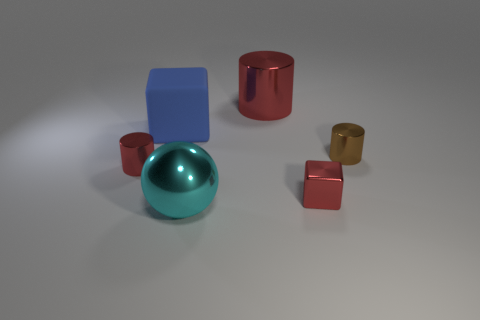There is a red object that is the same shape as the blue object; what material is it?
Make the answer very short. Metal. There is a cube behind the shiny cube; does it have the same size as the cyan metallic object?
Give a very brief answer. Yes. How many big blue things are behind the large cyan metallic object?
Keep it short and to the point. 1. Are there fewer small red cylinders to the right of the tiny red metal block than red shiny things in front of the large matte block?
Keep it short and to the point. Yes. How many big objects are there?
Provide a short and direct response. 3. The cube that is on the right side of the big cyan metal object is what color?
Provide a succinct answer. Red. The ball has what size?
Keep it short and to the point. Large. There is a big cylinder; does it have the same color as the small metallic object to the left of the large blue cube?
Keep it short and to the point. Yes. The cube that is behind the red cylinder that is left of the large blue rubber block is what color?
Your response must be concise. Blue. Is there anything else that has the same size as the brown metal cylinder?
Offer a very short reply. Yes. 